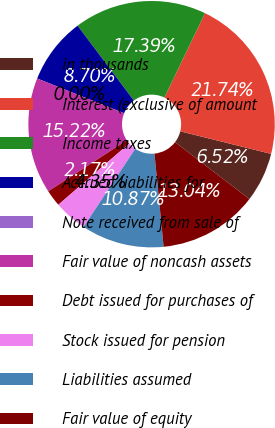<chart> <loc_0><loc_0><loc_500><loc_500><pie_chart><fcel>in thousands<fcel>Interest (exclusive of amount<fcel>Income taxes<fcel>Accrued liabilities for<fcel>Note received from sale of<fcel>Fair value of noncash assets<fcel>Debt issued for purchases of<fcel>Stock issued for pension<fcel>Liabilities assumed<fcel>Fair value of equity<nl><fcel>6.52%<fcel>21.74%<fcel>17.39%<fcel>8.7%<fcel>0.0%<fcel>15.22%<fcel>2.17%<fcel>4.35%<fcel>10.87%<fcel>13.04%<nl></chart> 